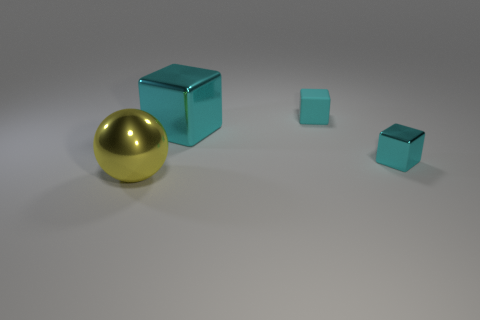How many cyan blocks must be subtracted to get 1 cyan blocks? 2 Add 1 small blocks. How many objects exist? 5 Subtract all blocks. How many objects are left? 1 Add 1 metal cubes. How many metal cubes are left? 3 Add 1 gray cylinders. How many gray cylinders exist? 1 Subtract 0 gray balls. How many objects are left? 4 Subtract all metallic things. Subtract all large spheres. How many objects are left? 0 